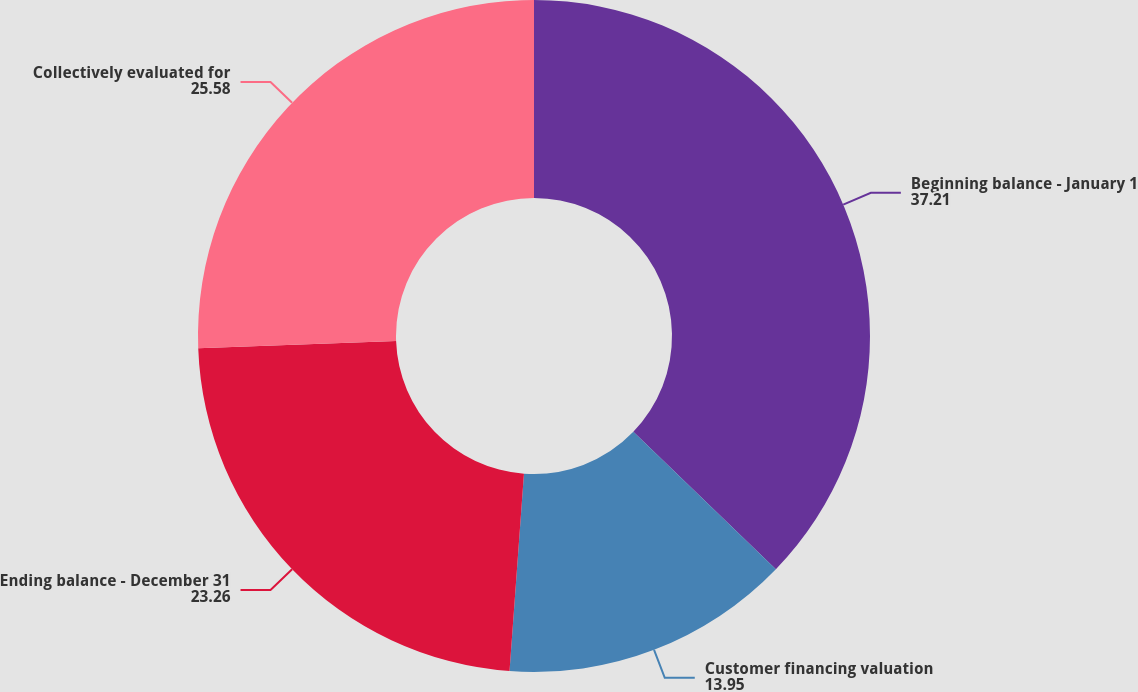Convert chart. <chart><loc_0><loc_0><loc_500><loc_500><pie_chart><fcel>Beginning balance - January 1<fcel>Customer financing valuation<fcel>Ending balance - December 31<fcel>Collectively evaluated for<nl><fcel>37.21%<fcel>13.95%<fcel>23.26%<fcel>25.58%<nl></chart> 